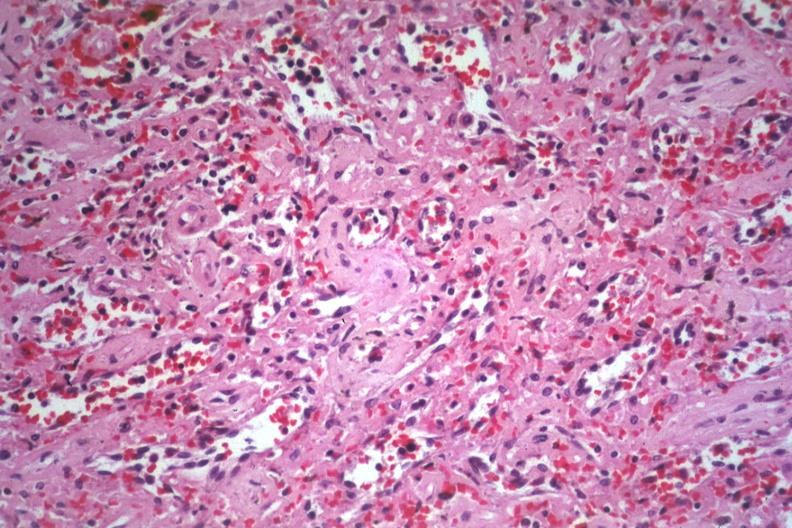s silver present?
Answer the question using a single word or phrase. No 